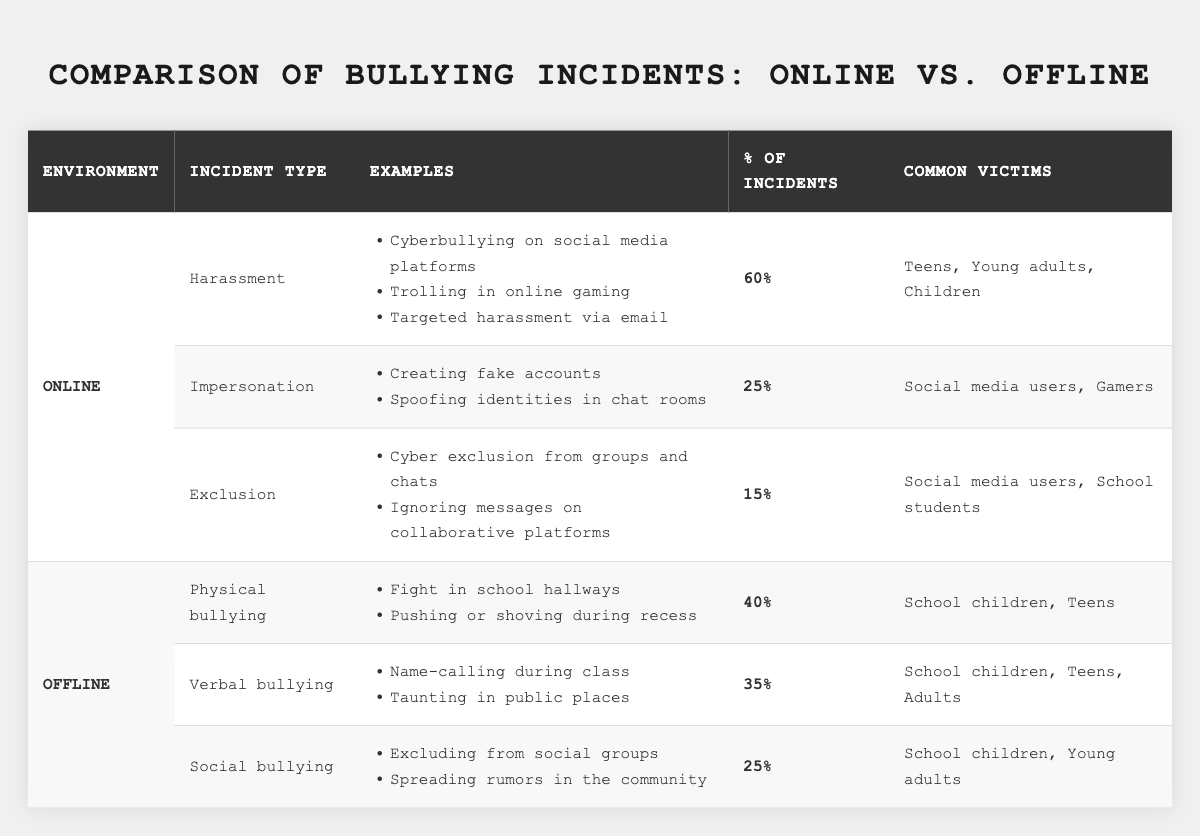What percentage of online bullying incidents are attributed to harassment? In the table under the "Online" environment, the incident type "Harassment" shows 60% of incidents.
Answer: 60% What type of bullying has the highest percentage in offline environments? Looking under the "Offline" environment, "Physical bullying" has 40%, which is higher than the other offline types listed.
Answer: Physical bullying Which incident type accounts for the least percentage of online bullying incidents? From the online section, "Exclusion" has the lowest percentage at 15%.
Answer: Exclusion What is the total percentage of offline bullying incidents that are either Physical or Verbal? Summing the percentages, Physical (40%) + Verbal (35%) equals 75%.
Answer: 75% Is it true that the common victims of online harassment include children? The data states that common victims of online harassment include "Teens, Young adults, Children," confirming that children are among the victims.
Answer: True What is the difference in percentage of bullying incidents between online harassment and offline physical bullying? Online harassment is at 60% and offline physical bullying is at 40%. The difference is 60% - 40% = 20%.
Answer: 20% If we consider the common victims, which group is not mentioned in the context of offline social bullying? Offline social bullying lists "School children, Young adults" as victims but does not mention "Adults," indicating they are not included.
Answer: Adults What percentage of total online incidents is related to impersonation? In the online section, impersonation accounts for 25% of incidents.
Answer: 25% Which type of bullying incident in offline settings has the highest number of common victim demographics? "Verbal bullying" has the most common victims listed as "School children, Teens, Adults," making it the highest.
Answer: Verbal bullying Which environment has a higher total of bullying incident percentages from the incident types listed? Adding for online, 60% + 25% + 15% = 100% and for offline, 40% + 35% + 25% = 100%. Both environments have equal total percentages.
Answer: Equal totals 